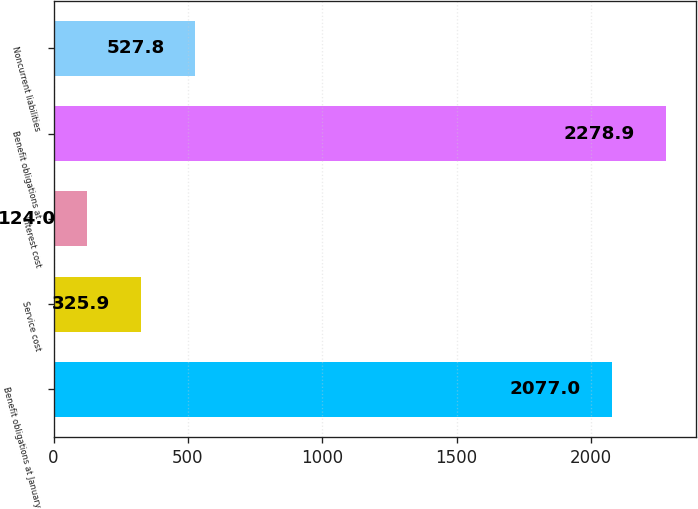<chart> <loc_0><loc_0><loc_500><loc_500><bar_chart><fcel>Benefit obligations at January<fcel>Service cost<fcel>Interest cost<fcel>Benefit obligations at<fcel>Noncurrent liabilities<nl><fcel>2077<fcel>325.9<fcel>124<fcel>2278.9<fcel>527.8<nl></chart> 